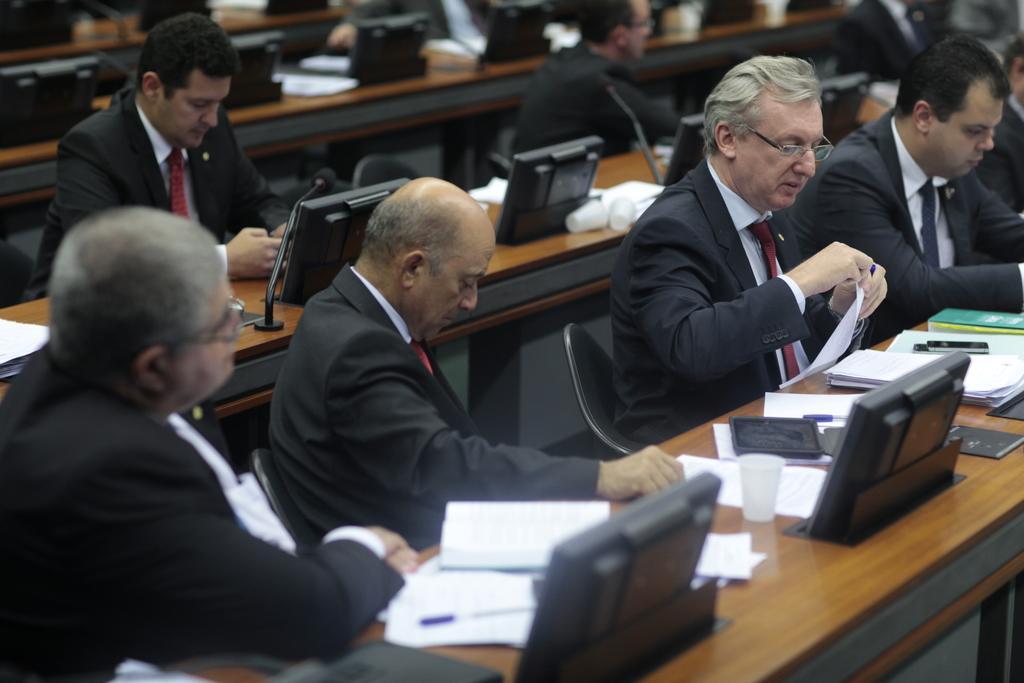How would you summarize this image in a sentence or two? As we can see in the image there are few people sitting on chairs and there is a tables. On table there are laptops, glasses and papers. 